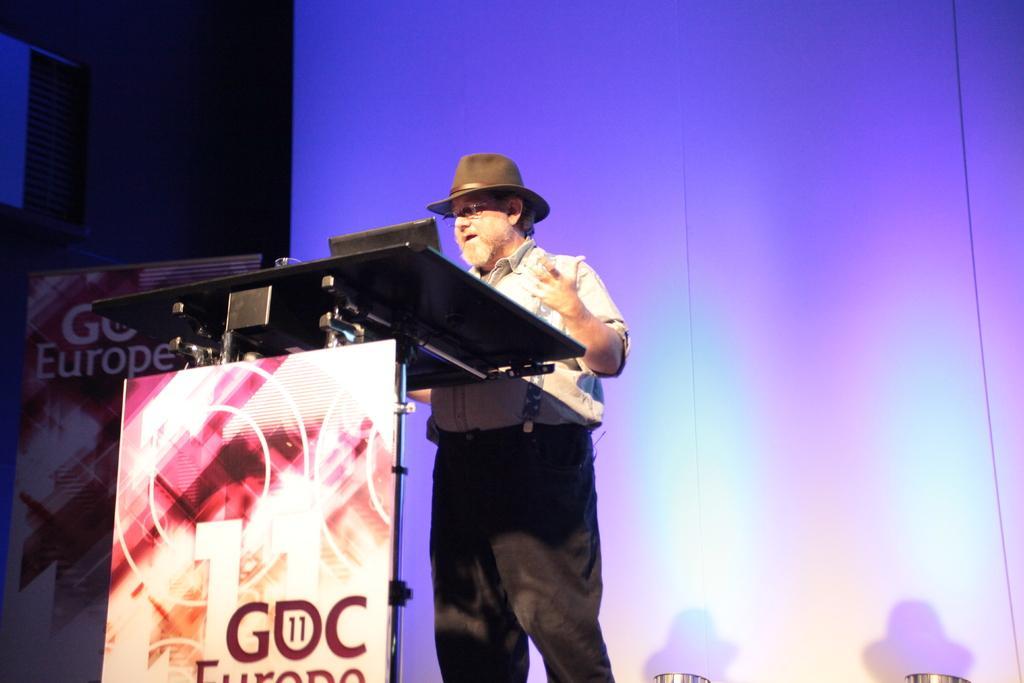In one or two sentences, can you explain what this image depicts? In the center of the image there is a person standing wearing a hat. In front of him there is a podium. In the background of the image there is a white color screen. At the bottom of the image there are lights. 